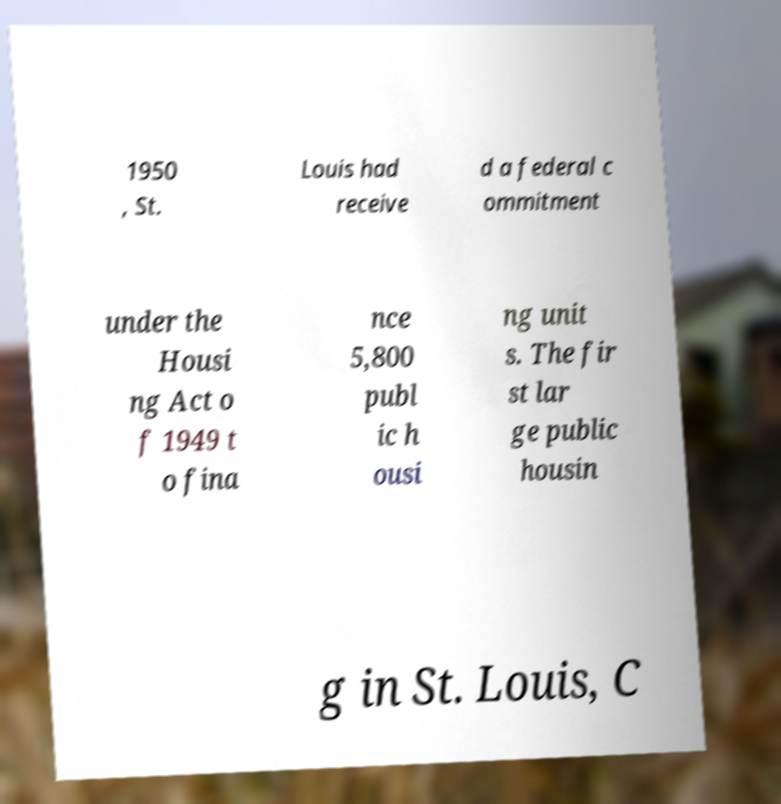Please read and relay the text visible in this image. What does it say? 1950 , St. Louis had receive d a federal c ommitment under the Housi ng Act o f 1949 t o fina nce 5,800 publ ic h ousi ng unit s. The fir st lar ge public housin g in St. Louis, C 